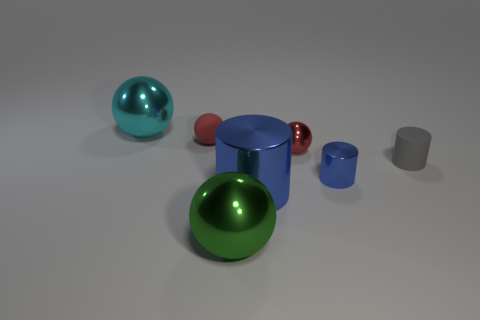Is the matte sphere the same color as the tiny metal ball?
Your response must be concise. Yes. What color is the big object that is left of the large shiny ball that is to the right of the cyan metallic ball?
Provide a short and direct response. Cyan. Is the green thing the same size as the gray matte cylinder?
Keep it short and to the point. No. What color is the sphere that is both behind the red metallic sphere and on the right side of the big cyan thing?
Offer a terse response. Red. How big is the gray rubber cylinder?
Keep it short and to the point. Small. There is a small thing left of the green sphere; is it the same color as the tiny rubber cylinder?
Your response must be concise. No. Are there more objects that are to the left of the green metallic ball than large objects to the right of the gray matte thing?
Give a very brief answer. Yes. Is the number of small red spheres greater than the number of big green shiny spheres?
Your answer should be compact. Yes. What size is the ball that is on the left side of the tiny metal sphere and in front of the small rubber sphere?
Your response must be concise. Large. There is a tiny red metal thing; what shape is it?
Your answer should be compact. Sphere. 